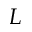Convert formula to latex. <formula><loc_0><loc_0><loc_500><loc_500>L</formula> 